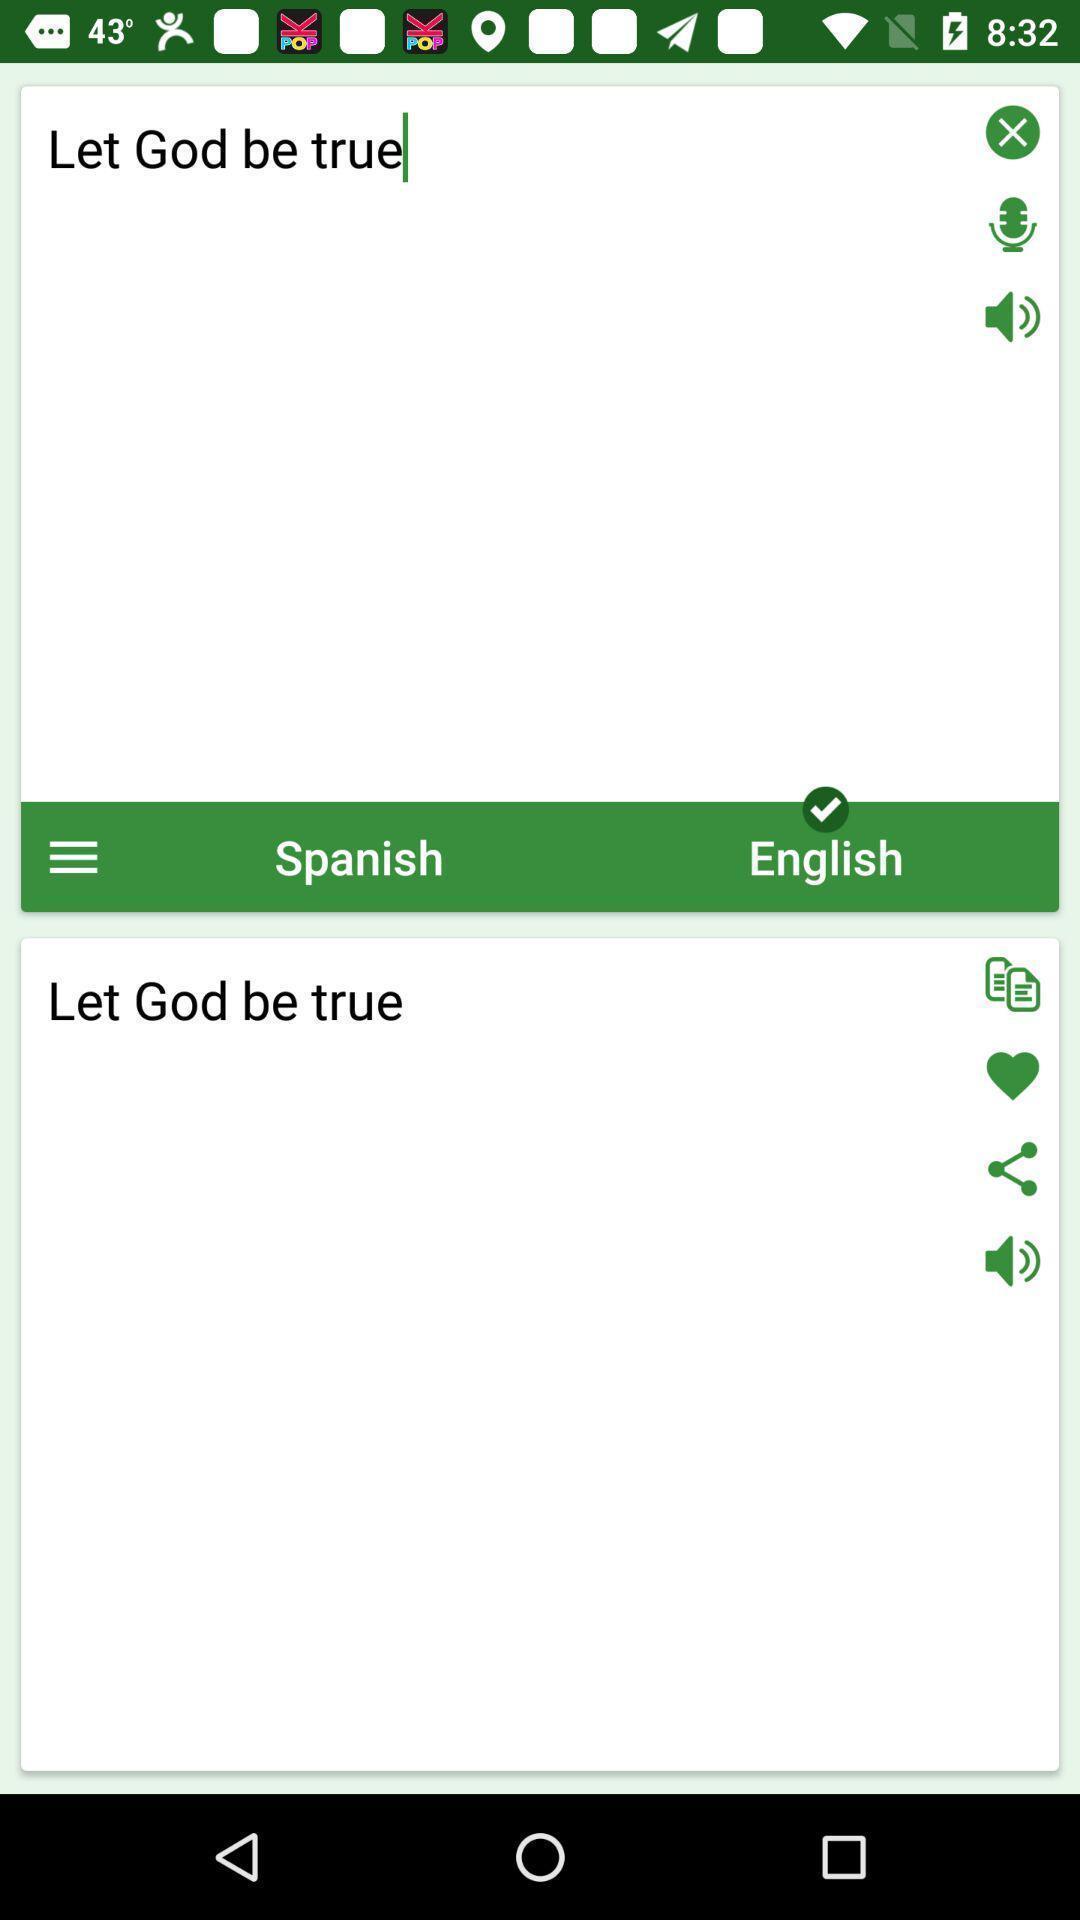Explain what's happening in this screen capture. Translator page. 